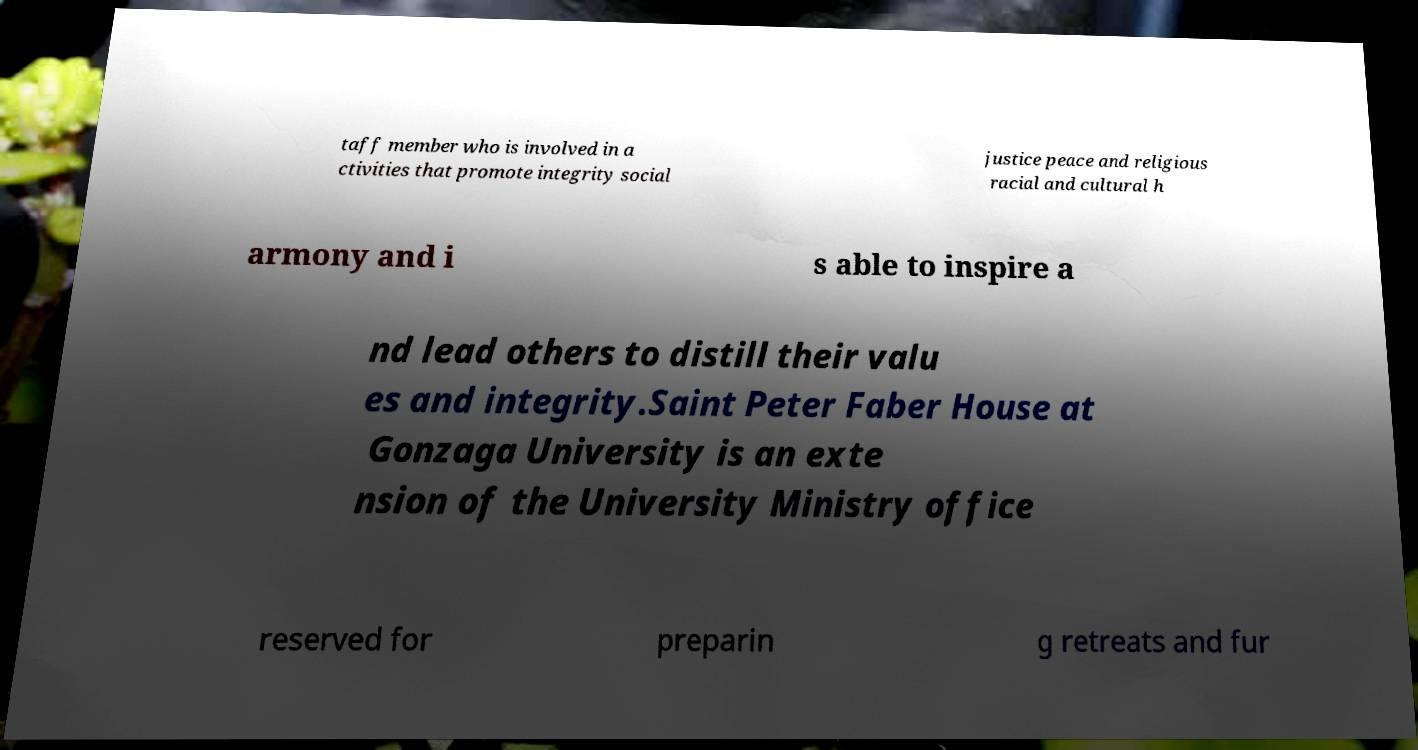Can you read and provide the text displayed in the image?This photo seems to have some interesting text. Can you extract and type it out for me? taff member who is involved in a ctivities that promote integrity social justice peace and religious racial and cultural h armony and i s able to inspire a nd lead others to distill their valu es and integrity.Saint Peter Faber House at Gonzaga University is an exte nsion of the University Ministry office reserved for preparin g retreats and fur 